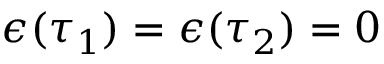Convert formula to latex. <formula><loc_0><loc_0><loc_500><loc_500>\epsilon ( \tau _ { 1 } ) = \epsilon ( \tau _ { 2 } ) = 0</formula> 